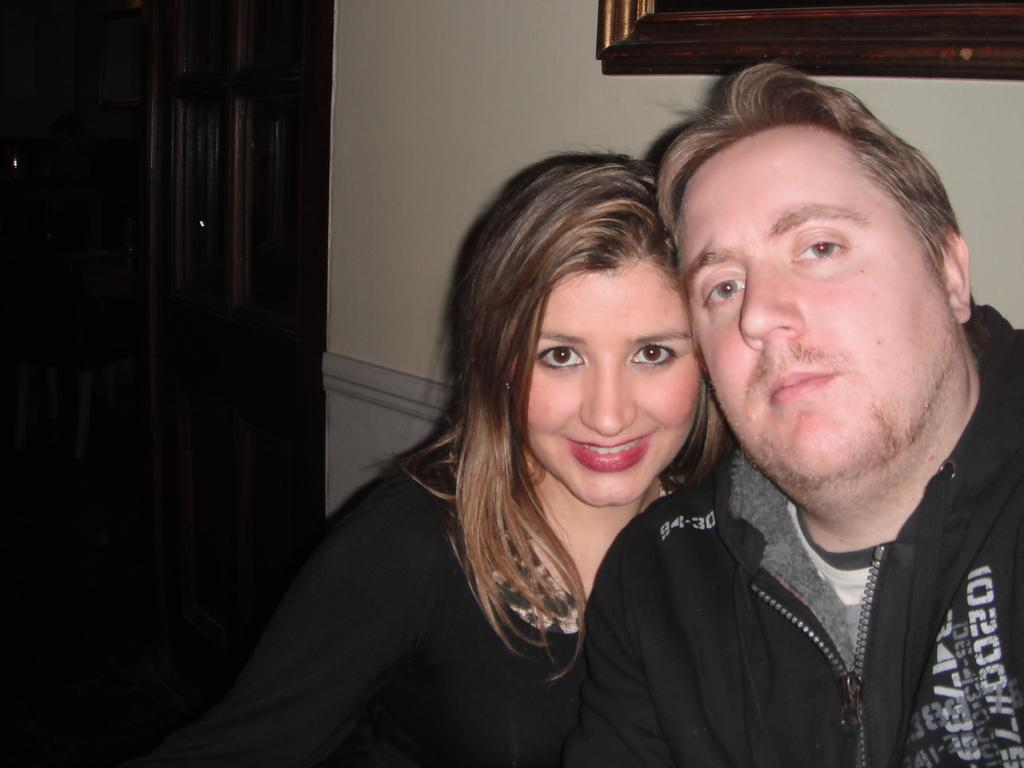How many people are in the picture? There are two people in the picture. What are the two people doing in the picture? The two people are posing for a photo. What can be seen in the background of the picture? There is a wall in the background of the picture. What is on the wall in the background? There is a frame on the wall. What architectural feature is on the left side of the wall? There is a door on the left side of the wall. How many beds can be seen in the picture? There are no beds visible in the picture. What type of bit is being used by the people in the picture? There is no bit present in the picture; the two people are posing for a photo. 